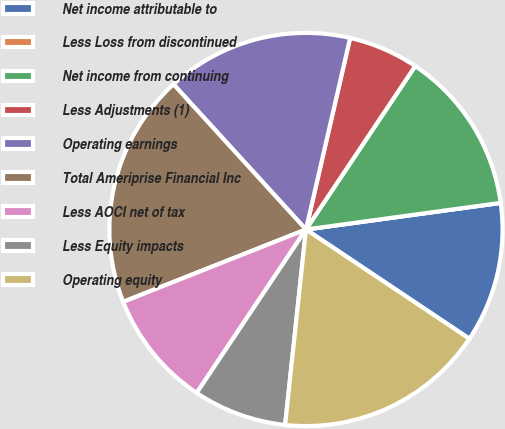<chart> <loc_0><loc_0><loc_500><loc_500><pie_chart><fcel>Net income attributable to<fcel>Less Loss from discontinued<fcel>Net income from continuing<fcel>Less Adjustments (1)<fcel>Operating earnings<fcel>Total Ameriprise Financial Inc<fcel>Less AOCI net of tax<fcel>Less Equity impacts<fcel>Operating equity<nl><fcel>11.54%<fcel>0.0%<fcel>13.46%<fcel>5.77%<fcel>15.38%<fcel>19.23%<fcel>9.62%<fcel>7.69%<fcel>17.31%<nl></chart> 